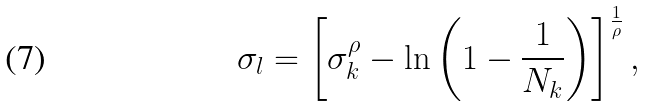Convert formula to latex. <formula><loc_0><loc_0><loc_500><loc_500>\sigma _ { l } = \left [ \sigma _ { k } ^ { \rho } - \ln \left ( 1 - \frac { 1 } { N _ { k } } \right ) \right ] ^ { \frac { 1 } { \rho } } ,</formula> 